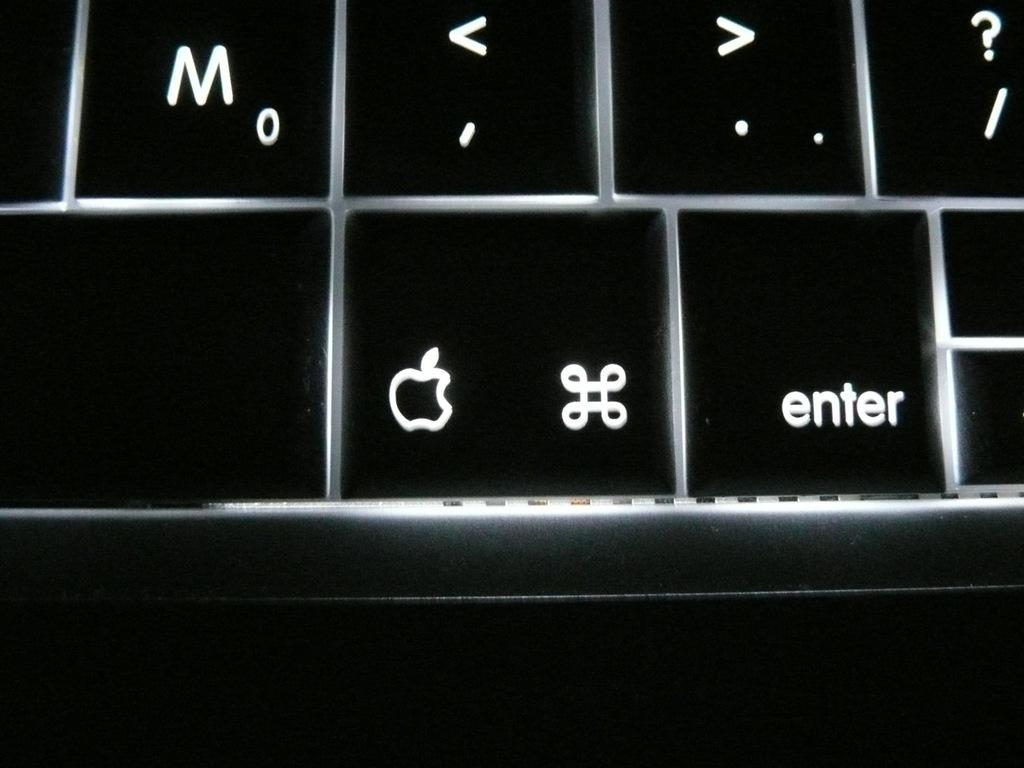<image>
Create a compact narrative representing the image presented. A black keyboard with the Apple logo on a key. 